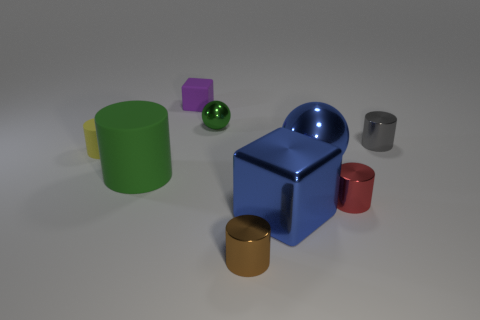There is a large blue metallic thing behind the green object that is to the left of the matte block; is there a cylinder that is to the left of it?
Ensure brevity in your answer.  Yes. There is a blue object to the right of the blue metal block; what material is it?
Your answer should be very brief. Metal. Does the brown shiny thing have the same shape as the object left of the big cylinder?
Offer a terse response. Yes. Are there the same number of big green cylinders that are to the right of the tiny brown thing and blue objects in front of the green cylinder?
Offer a terse response. No. What number of other objects are there of the same material as the large green cylinder?
Ensure brevity in your answer.  2. What number of metallic things are small purple blocks or balls?
Your response must be concise. 2. There is a small matte thing that is on the left side of the green matte cylinder; is it the same shape as the big green rubber object?
Make the answer very short. Yes. Are there more brown cylinders in front of the purple cube than small gray rubber spheres?
Your answer should be very brief. Yes. What number of objects are to the right of the purple object and behind the gray shiny cylinder?
Your answer should be compact. 1. The cube that is behind the sphere to the left of the brown thing is what color?
Give a very brief answer. Purple. 